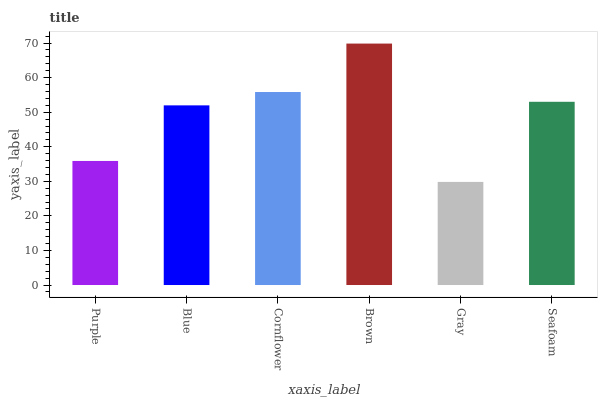Is Gray the minimum?
Answer yes or no. Yes. Is Brown the maximum?
Answer yes or no. Yes. Is Blue the minimum?
Answer yes or no. No. Is Blue the maximum?
Answer yes or no. No. Is Blue greater than Purple?
Answer yes or no. Yes. Is Purple less than Blue?
Answer yes or no. Yes. Is Purple greater than Blue?
Answer yes or no. No. Is Blue less than Purple?
Answer yes or no. No. Is Seafoam the high median?
Answer yes or no. Yes. Is Blue the low median?
Answer yes or no. Yes. Is Brown the high median?
Answer yes or no. No. Is Gray the low median?
Answer yes or no. No. 